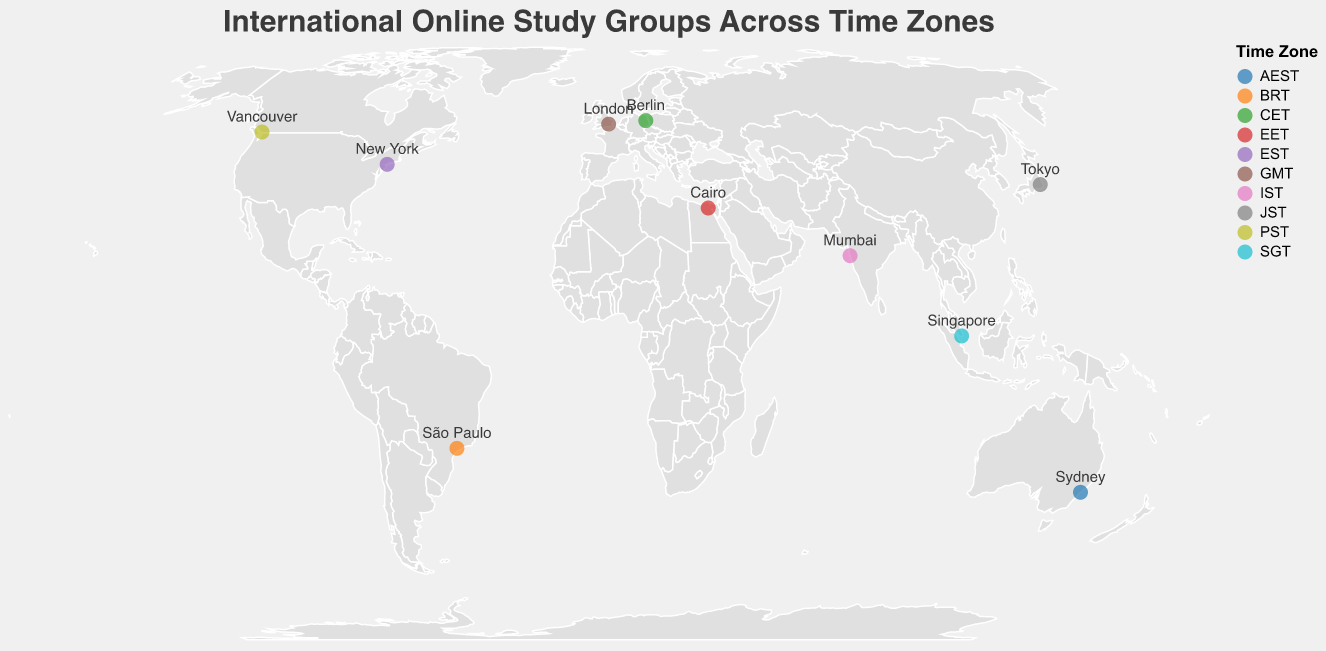What is the title of the figure? The title of the figure is located at the top and usually describes the main topic or purpose of the plot. In this case, the title conveys information about the distribution of online study groups across different time zones.
Answer: International Online Study Groups Across Time Zones How many study groups are displayed on the map? By observing the number of circles or points plotted on the map, we can count the total number of study groups. Each circle represents a different study group.
Answer: 10 Which city has the earliest meeting time mentioned in the figure? Examine the tooltip information for each study group. Locate the meeting times and identify the earliest one by comparing them.
Answer: Vancouver Which time zone has the most study groups? Look at the colors used to represent different time zones. Count the number of circles corresponding to each color and determine which time zone appears most frequently.
Answer: Each time zone has 1 study group What is the time difference between the study groups in New York and Sydney? Find the meeting times for New York and Sydney from the figure. Calculate the time difference by considering the different time zones and comparing the specific meeting times.
Answer: New York (20:00 EST) and Sydney (18:00 AEST); time difference is 16 hours ahead for Sydney Which study group meets in the afternoon according to their local time? Check the meeting times of each study group and cross-reference them with their respective cities' local times. Identify the groups that have meetings between 12:00 PM and 6:00 PM.
Answer: "Business Case Analysis" in Singapore (15:00 SGT), "Philosophy Thinkers Club" in Berlin (14:00 CET), and "Ancient Civilizations Study" in Cairo (16:00 EET) Compare the meeting times of the "Coding Champions" and "Language Exchange Group." Which group meets later according to their local time? Look at the meeting times of "Coding Champions" and "Language Exchange Group" and compare them directly by focusing on their local times.
Answer: "Coding Champions" in Mumbai meets at 21:30 IST, which is later than "Language Exchange Group" in São Paulo at 17:00 BRT Which city has its study group meeting at 09:00 local time? Identify the city by finding the study group whose meeting time is listed as 09:00 in the figure. Observe the tooltips to verify this information.
Answer: Vancouver 